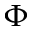Convert formula to latex. <formula><loc_0><loc_0><loc_500><loc_500>\Phi</formula> 